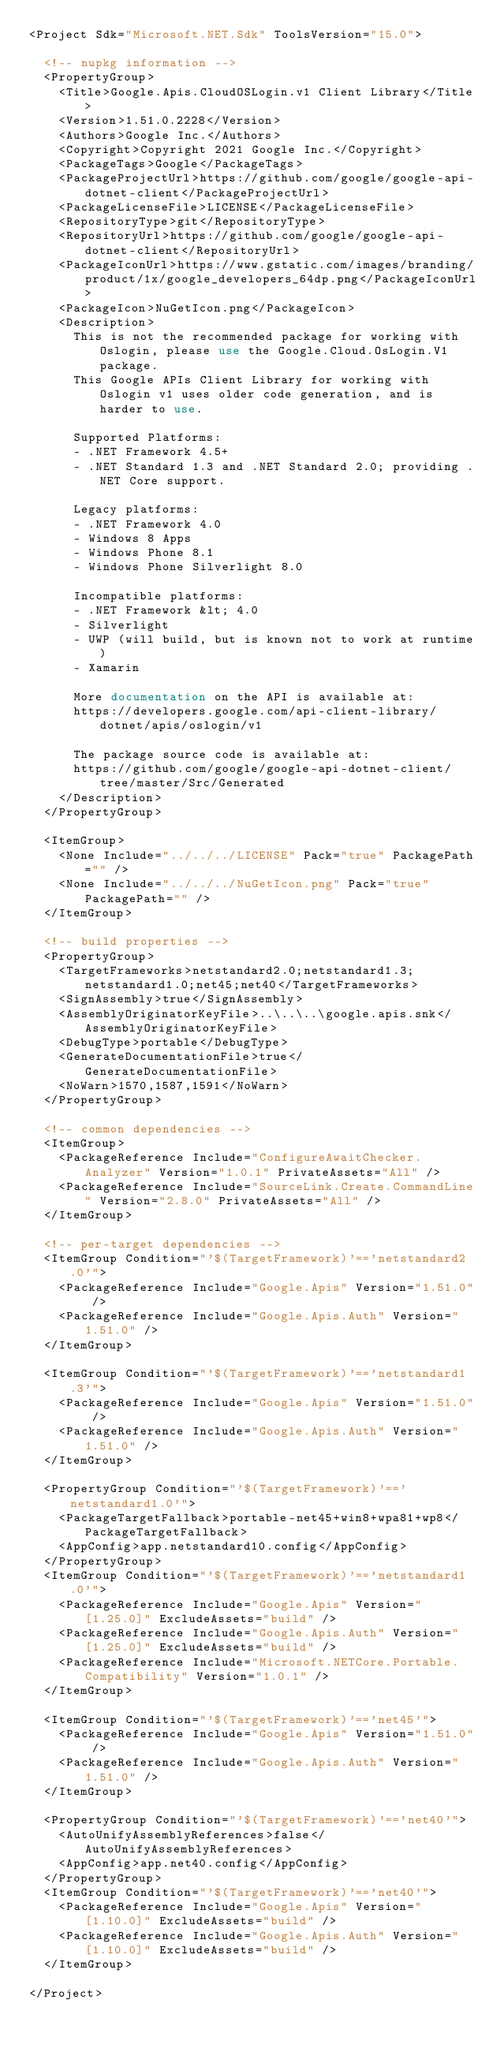Convert code to text. <code><loc_0><loc_0><loc_500><loc_500><_XML_><Project Sdk="Microsoft.NET.Sdk" ToolsVersion="15.0">

  <!-- nupkg information -->
  <PropertyGroup>
    <Title>Google.Apis.CloudOSLogin.v1 Client Library</Title>
    <Version>1.51.0.2228</Version>
    <Authors>Google Inc.</Authors>
    <Copyright>Copyright 2021 Google Inc.</Copyright>
    <PackageTags>Google</PackageTags>
    <PackageProjectUrl>https://github.com/google/google-api-dotnet-client</PackageProjectUrl>
    <PackageLicenseFile>LICENSE</PackageLicenseFile>
    <RepositoryType>git</RepositoryType>
    <RepositoryUrl>https://github.com/google/google-api-dotnet-client</RepositoryUrl>
    <PackageIconUrl>https://www.gstatic.com/images/branding/product/1x/google_developers_64dp.png</PackageIconUrl>
    <PackageIcon>NuGetIcon.png</PackageIcon>
    <Description>
      This is not the recommended package for working with Oslogin, please use the Google.Cloud.OsLogin.V1 package.
      This Google APIs Client Library for working with Oslogin v1 uses older code generation, and is harder to use.

      Supported Platforms:
      - .NET Framework 4.5+
      - .NET Standard 1.3 and .NET Standard 2.0; providing .NET Core support.

      Legacy platforms:
      - .NET Framework 4.0
      - Windows 8 Apps
      - Windows Phone 8.1
      - Windows Phone Silverlight 8.0

      Incompatible platforms:
      - .NET Framework &lt; 4.0
      - Silverlight
      - UWP (will build, but is known not to work at runtime)
      - Xamarin

      More documentation on the API is available at:
      https://developers.google.com/api-client-library/dotnet/apis/oslogin/v1

      The package source code is available at:
      https://github.com/google/google-api-dotnet-client/tree/master/Src/Generated
    </Description>
  </PropertyGroup>

  <ItemGroup>
    <None Include="../../../LICENSE" Pack="true" PackagePath="" />
    <None Include="../../../NuGetIcon.png" Pack="true" PackagePath="" />
  </ItemGroup>

  <!-- build properties -->
  <PropertyGroup>
    <TargetFrameworks>netstandard2.0;netstandard1.3;netstandard1.0;net45;net40</TargetFrameworks>
    <SignAssembly>true</SignAssembly>
    <AssemblyOriginatorKeyFile>..\..\..\google.apis.snk</AssemblyOriginatorKeyFile>
    <DebugType>portable</DebugType>
    <GenerateDocumentationFile>true</GenerateDocumentationFile>
    <NoWarn>1570,1587,1591</NoWarn>
  </PropertyGroup>

  <!-- common dependencies -->
  <ItemGroup>
    <PackageReference Include="ConfigureAwaitChecker.Analyzer" Version="1.0.1" PrivateAssets="All" />
    <PackageReference Include="SourceLink.Create.CommandLine" Version="2.8.0" PrivateAssets="All" />
  </ItemGroup>

  <!-- per-target dependencies -->
  <ItemGroup Condition="'$(TargetFramework)'=='netstandard2.0'">
    <PackageReference Include="Google.Apis" Version="1.51.0" />
    <PackageReference Include="Google.Apis.Auth" Version="1.51.0" />
  </ItemGroup>

  <ItemGroup Condition="'$(TargetFramework)'=='netstandard1.3'">
    <PackageReference Include="Google.Apis" Version="1.51.0" />
    <PackageReference Include="Google.Apis.Auth" Version="1.51.0" />
  </ItemGroup>

  <PropertyGroup Condition="'$(TargetFramework)'=='netstandard1.0'">
    <PackageTargetFallback>portable-net45+win8+wpa81+wp8</PackageTargetFallback>
    <AppConfig>app.netstandard10.config</AppConfig>
  </PropertyGroup>
  <ItemGroup Condition="'$(TargetFramework)'=='netstandard1.0'">
    <PackageReference Include="Google.Apis" Version="[1.25.0]" ExcludeAssets="build" />
    <PackageReference Include="Google.Apis.Auth" Version="[1.25.0]" ExcludeAssets="build" />
    <PackageReference Include="Microsoft.NETCore.Portable.Compatibility" Version="1.0.1" />
  </ItemGroup>

  <ItemGroup Condition="'$(TargetFramework)'=='net45'">
    <PackageReference Include="Google.Apis" Version="1.51.0" />
    <PackageReference Include="Google.Apis.Auth" Version="1.51.0" />
  </ItemGroup>

  <PropertyGroup Condition="'$(TargetFramework)'=='net40'">
    <AutoUnifyAssemblyReferences>false</AutoUnifyAssemblyReferences>
    <AppConfig>app.net40.config</AppConfig>
  </PropertyGroup>
  <ItemGroup Condition="'$(TargetFramework)'=='net40'">
    <PackageReference Include="Google.Apis" Version="[1.10.0]" ExcludeAssets="build" />
    <PackageReference Include="Google.Apis.Auth" Version="[1.10.0]" ExcludeAssets="build" />
  </ItemGroup>

</Project>
</code> 